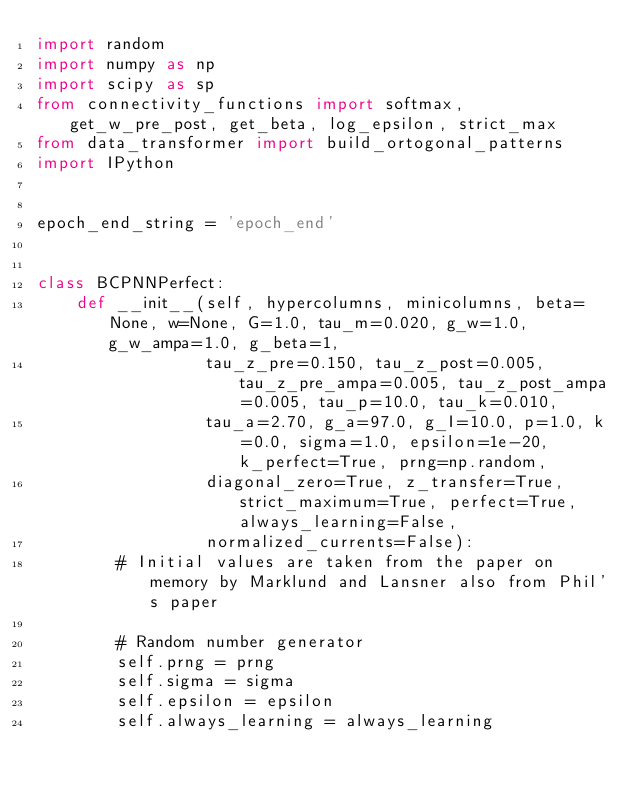<code> <loc_0><loc_0><loc_500><loc_500><_Python_>import random
import numpy as np
import scipy as sp
from connectivity_functions import softmax, get_w_pre_post, get_beta, log_epsilon, strict_max
from data_transformer import build_ortogonal_patterns
import IPython


epoch_end_string = 'epoch_end'


class BCPNNPerfect:
    def __init__(self, hypercolumns, minicolumns, beta=None, w=None, G=1.0, tau_m=0.020, g_w=1.0, g_w_ampa=1.0, g_beta=1,
                 tau_z_pre=0.150, tau_z_post=0.005, tau_z_pre_ampa=0.005, tau_z_post_ampa=0.005, tau_p=10.0, tau_k=0.010,
                 tau_a=2.70, g_a=97.0, g_I=10.0, p=1.0, k=0.0, sigma=1.0, epsilon=1e-20, k_perfect=True, prng=np.random,
                 diagonal_zero=True, z_transfer=True, strict_maximum=True, perfect=True, always_learning=False,
                 normalized_currents=False):
        # Initial values are taken from the paper on memory by Marklund and Lansner also from Phil's paper

        # Random number generator
        self.prng = prng
        self.sigma = sigma
        self.epsilon = epsilon
        self.always_learning = always_learning</code> 